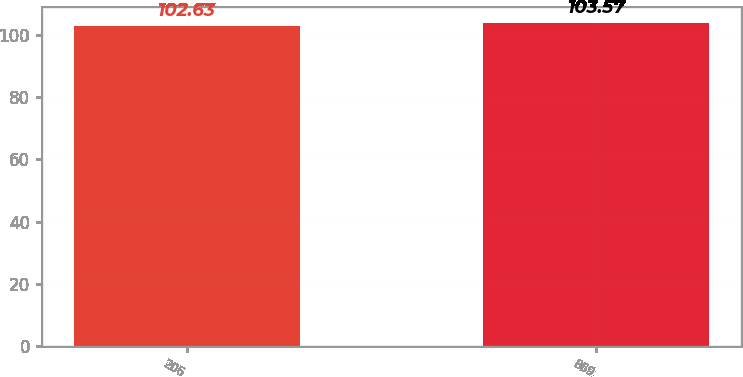<chart> <loc_0><loc_0><loc_500><loc_500><bar_chart><fcel>206<fcel>869<nl><fcel>102.63<fcel>103.57<nl></chart> 